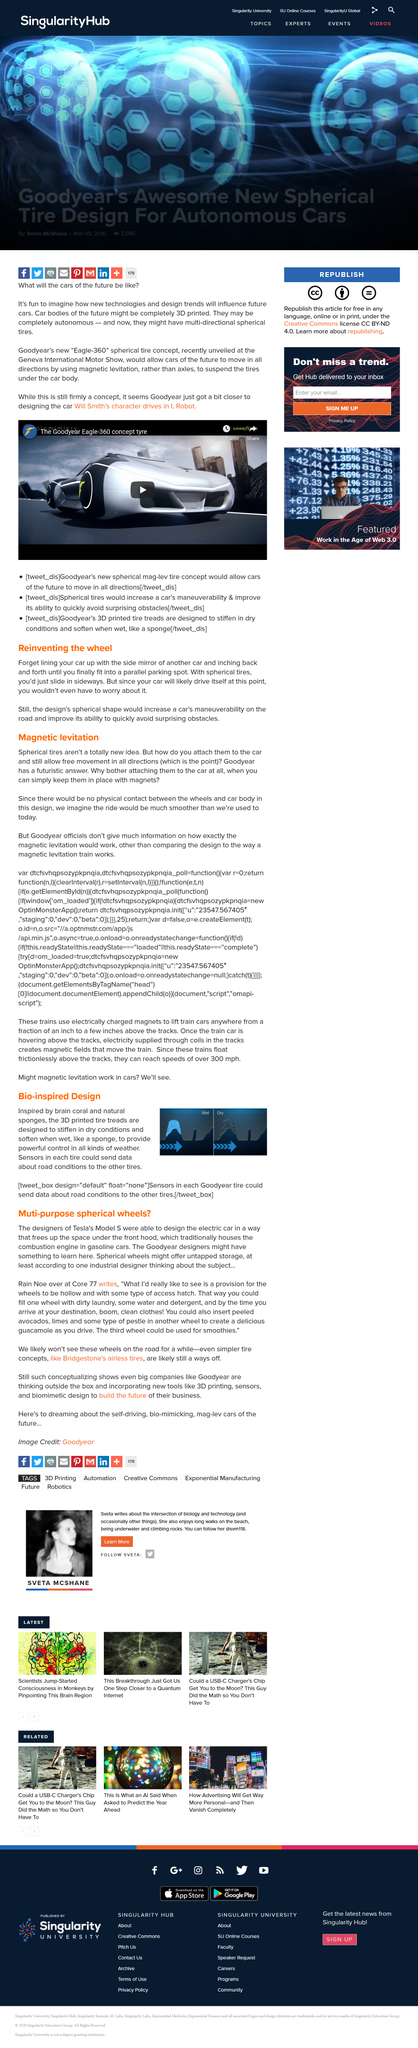Highlight a few significant elements in this photo. Bio-inspired design is inspired by the innovative features of brain coral and natural sponges. Rain Noe is employed by Core 77. The 3D printed tire treads are designed to stiffen in dry conditions and soften when wet, behaving like a sponge, for improved traction and safety on the road. The Eagle-360 tire is a revolutionary invention that enables vehicles to move in all directions using magnetic levitation. This innovative technology allows for unparalleled mobility and flexibility, enabling cars to effortlessly navigate through any terrain. With the Eagle-360 tire, the future of transportation is here, and it is poised to change the way we think about mobility and convenience. According to one industrial designer, spherical wheels on a Tesla Model S could offer untapped storage potential. 